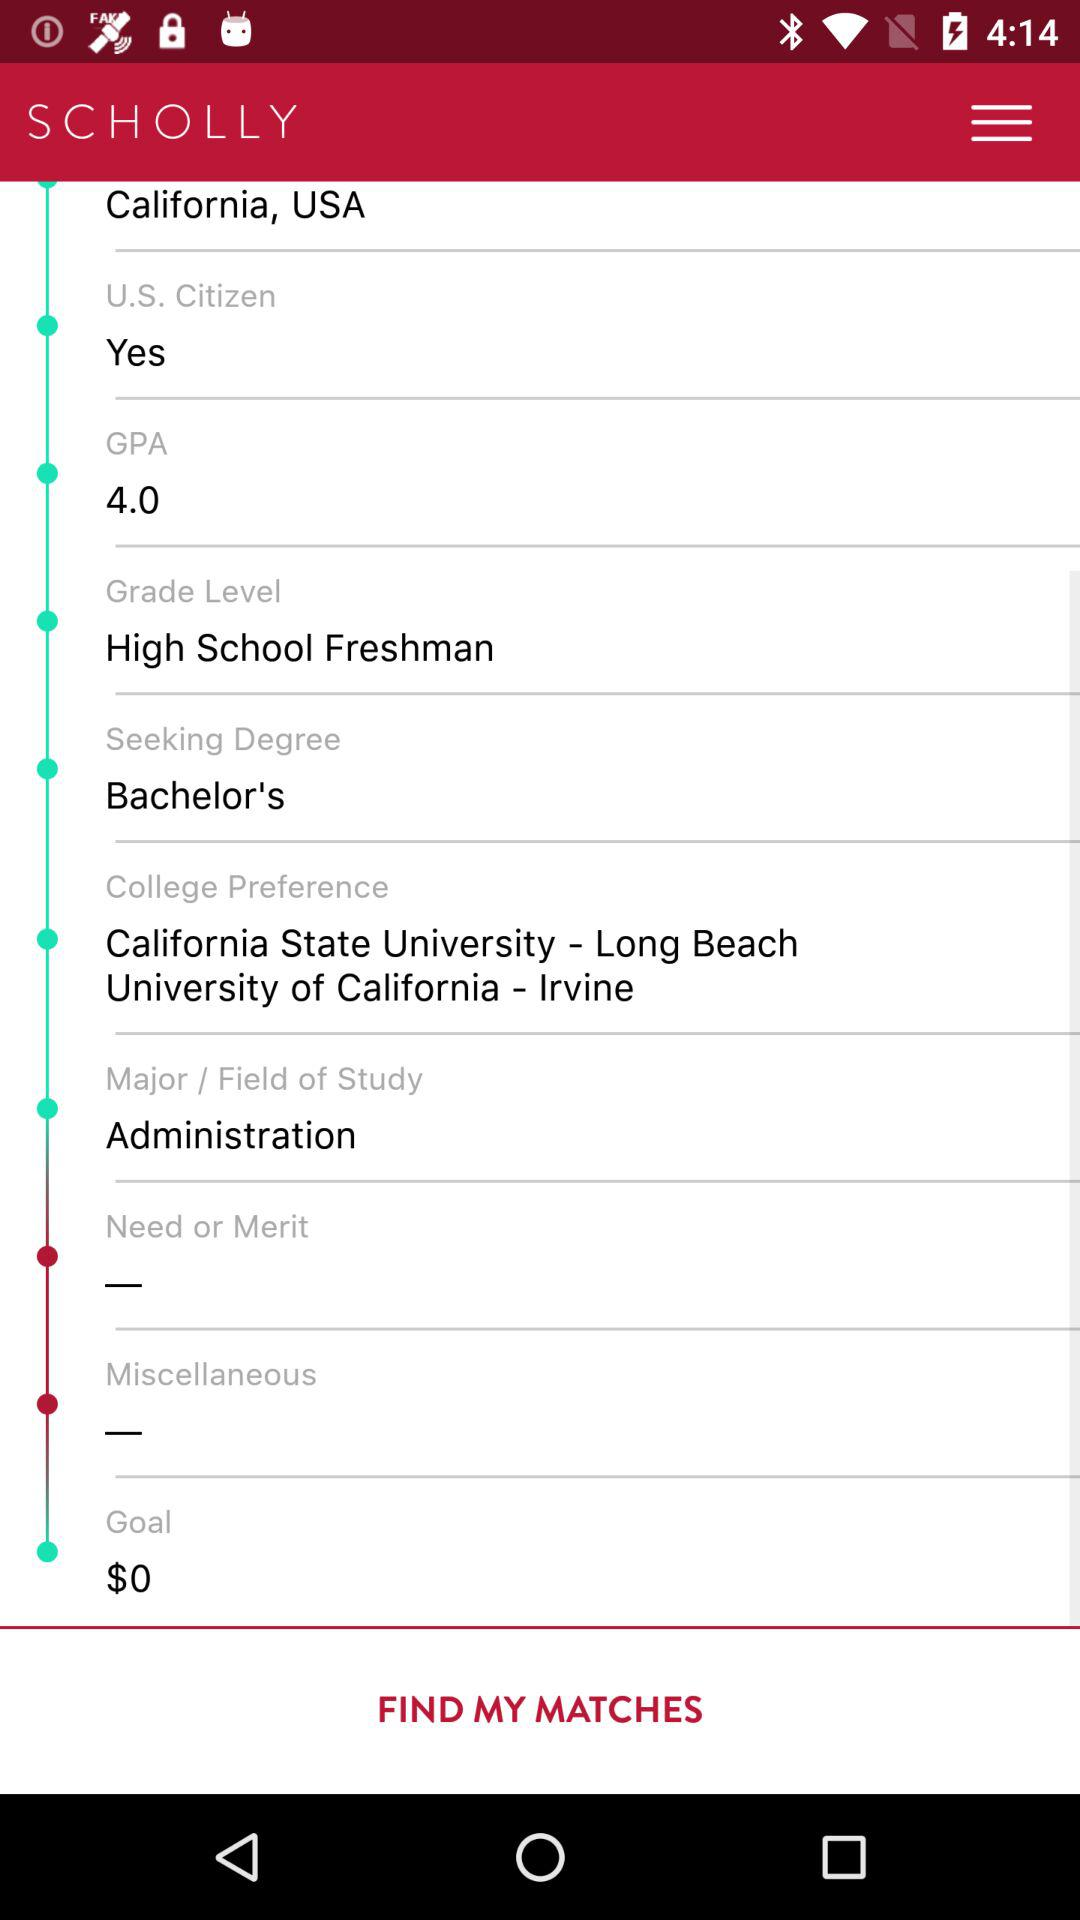What is the "Major/Field of Study"? The "Major/Field of Study" is administration. 